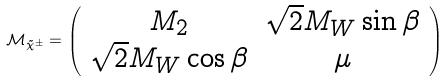Convert formula to latex. <formula><loc_0><loc_0><loc_500><loc_500>\mathcal { M } _ { \tilde { \chi } ^ { \pm } } = \left ( \begin{array} { c c } M _ { 2 } & \sqrt { 2 } M _ { W } \sin \beta \\ \sqrt { 2 } M _ { W } \cos \beta & \mu \end{array} \right )</formula> 